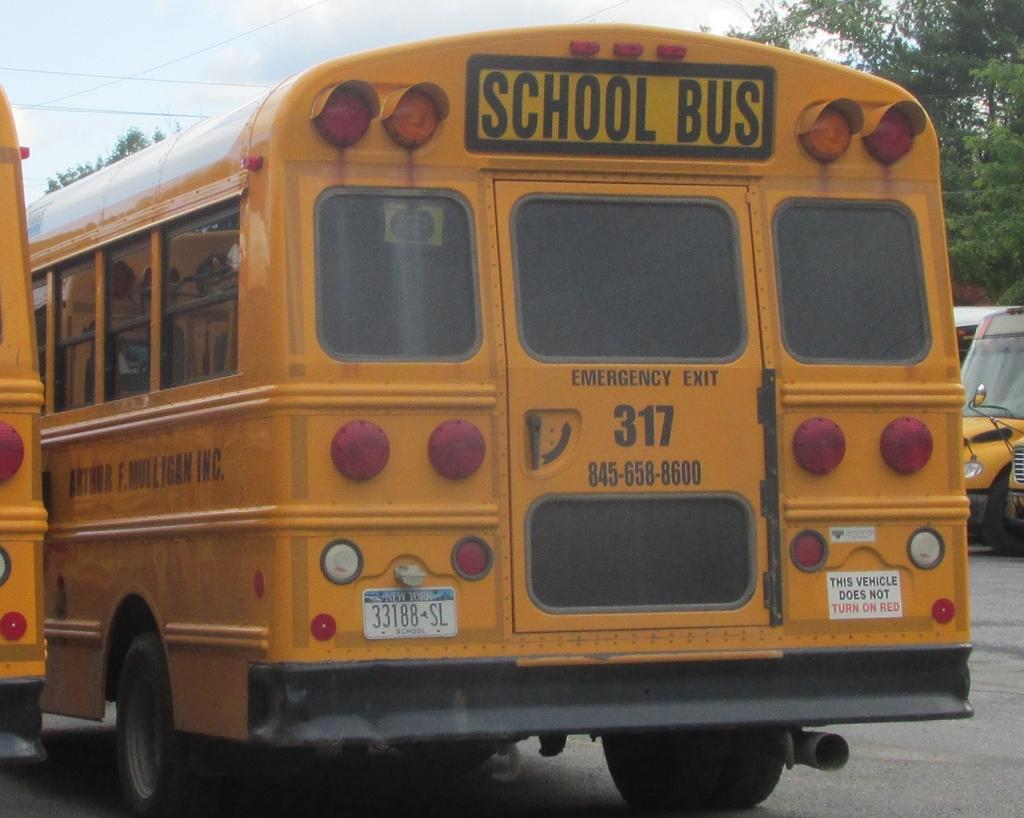What type of vehicles on the road in the image? There are school buses on the road in the image. What can be seen on the left side of the image? There are trees on the left side of the image. What is visible in the background of the image? The sky is visible in the image. What is the condition of the sky in the image? Clouds are present in the sky. What type of sack is being used to polish the fowl in the image? There is no sack, polish, or fowl present in the image. 